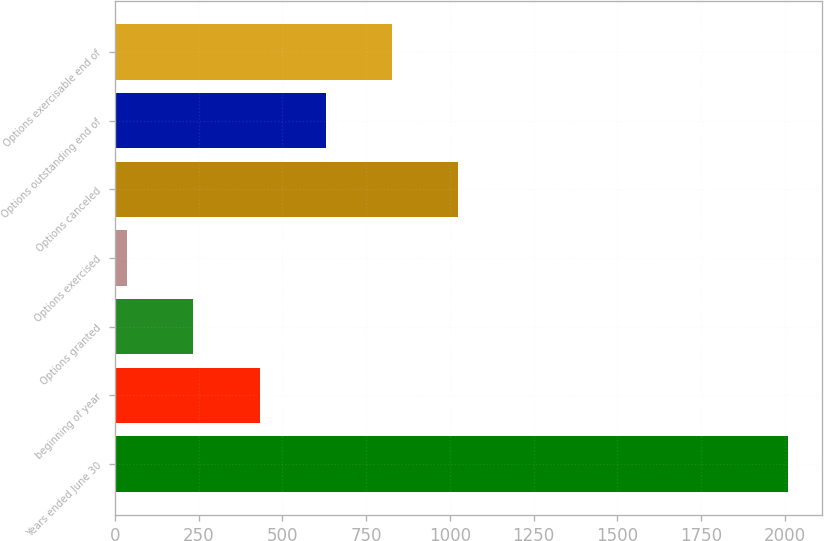Convert chart. <chart><loc_0><loc_0><loc_500><loc_500><bar_chart><fcel>Years ended June 30<fcel>beginning of year<fcel>Options granted<fcel>Options exercised<fcel>Options canceled<fcel>Options outstanding end of<fcel>Options exercisable end of<nl><fcel>2010<fcel>431.6<fcel>234.3<fcel>37<fcel>1023.5<fcel>628.9<fcel>826.2<nl></chart> 